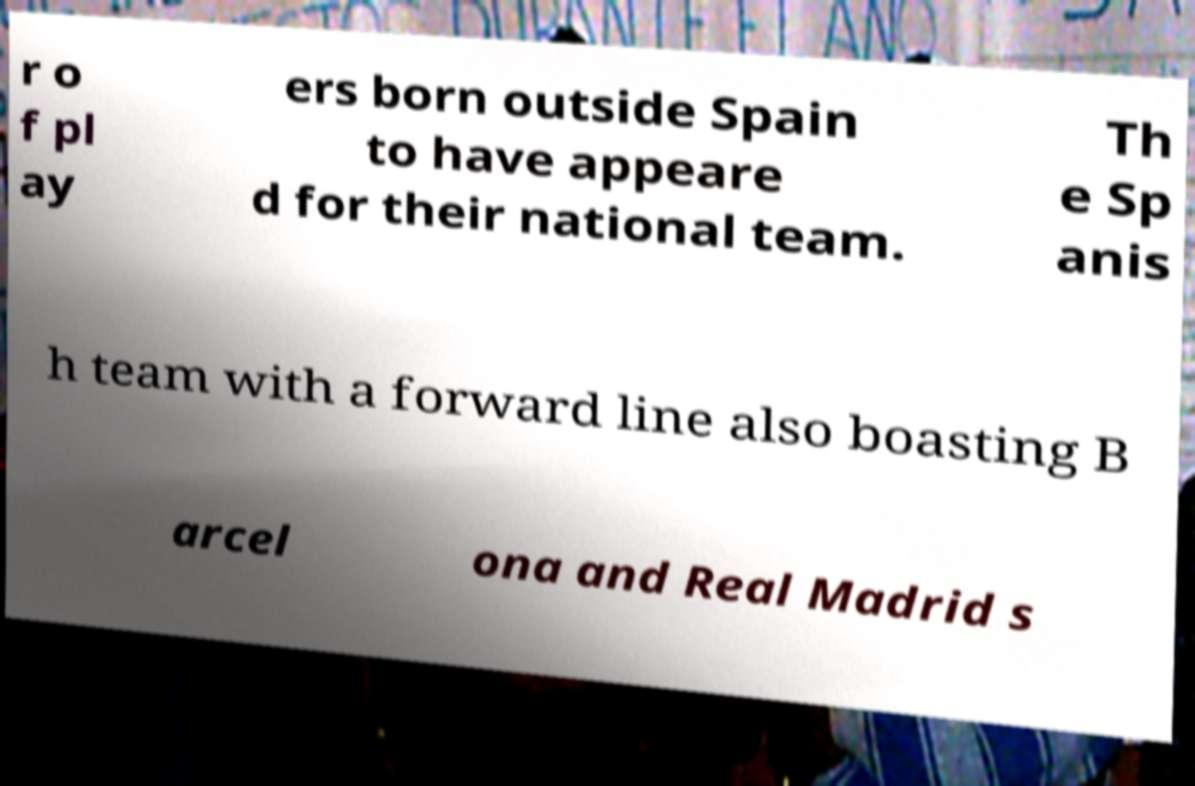Please read and relay the text visible in this image. What does it say? r o f pl ay ers born outside Spain to have appeare d for their national team. Th e Sp anis h team with a forward line also boasting B arcel ona and Real Madrid s 